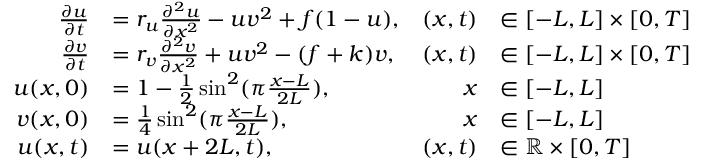<formula> <loc_0><loc_0><loc_500><loc_500>\begin{array} { r l r l } { \frac { \partial u } { \partial t } } & { = r _ { u } \frac { \partial ^ { 2 } u } { \partial x ^ { 2 } } - u v ^ { 2 } + f ( 1 - u ) , } & { ( x , t ) } & { \in [ - L , L ] \times [ 0 , T ] } \\ { \frac { \partial v } { \partial t } } & { = r _ { v } \frac { \partial ^ { 2 } v } { \partial x ^ { 2 } } + u v ^ { 2 } - ( f + k ) v , } & { ( x , t ) } & { \in [ - L , L ] \times [ 0 , T ] } \\ { u ( x , 0 ) } & { = 1 - \frac { 1 } { 2 } \sin ^ { 2 } ( \pi \frac { x - L } { 2 L } ) , } & { x } & { \in [ - L , L ] } \\ { v ( x , 0 ) } & { = \frac { 1 } { 4 } \sin ^ { 2 } ( \pi \frac { x - L } { 2 L } ) , } & { x } & { \in [ - L , L ] } \\ { u ( x , t ) } & { = u ( x + 2 L , t ) , } & { ( x , t ) } & { \in \mathbb { R } \times [ 0 , T ] } \end{array}</formula> 